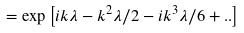Convert formula to latex. <formula><loc_0><loc_0><loc_500><loc_500>= \exp \left [ i k \lambda - k ^ { 2 } \lambda / 2 - i k ^ { 3 } \lambda / 6 + . . \right ]</formula> 